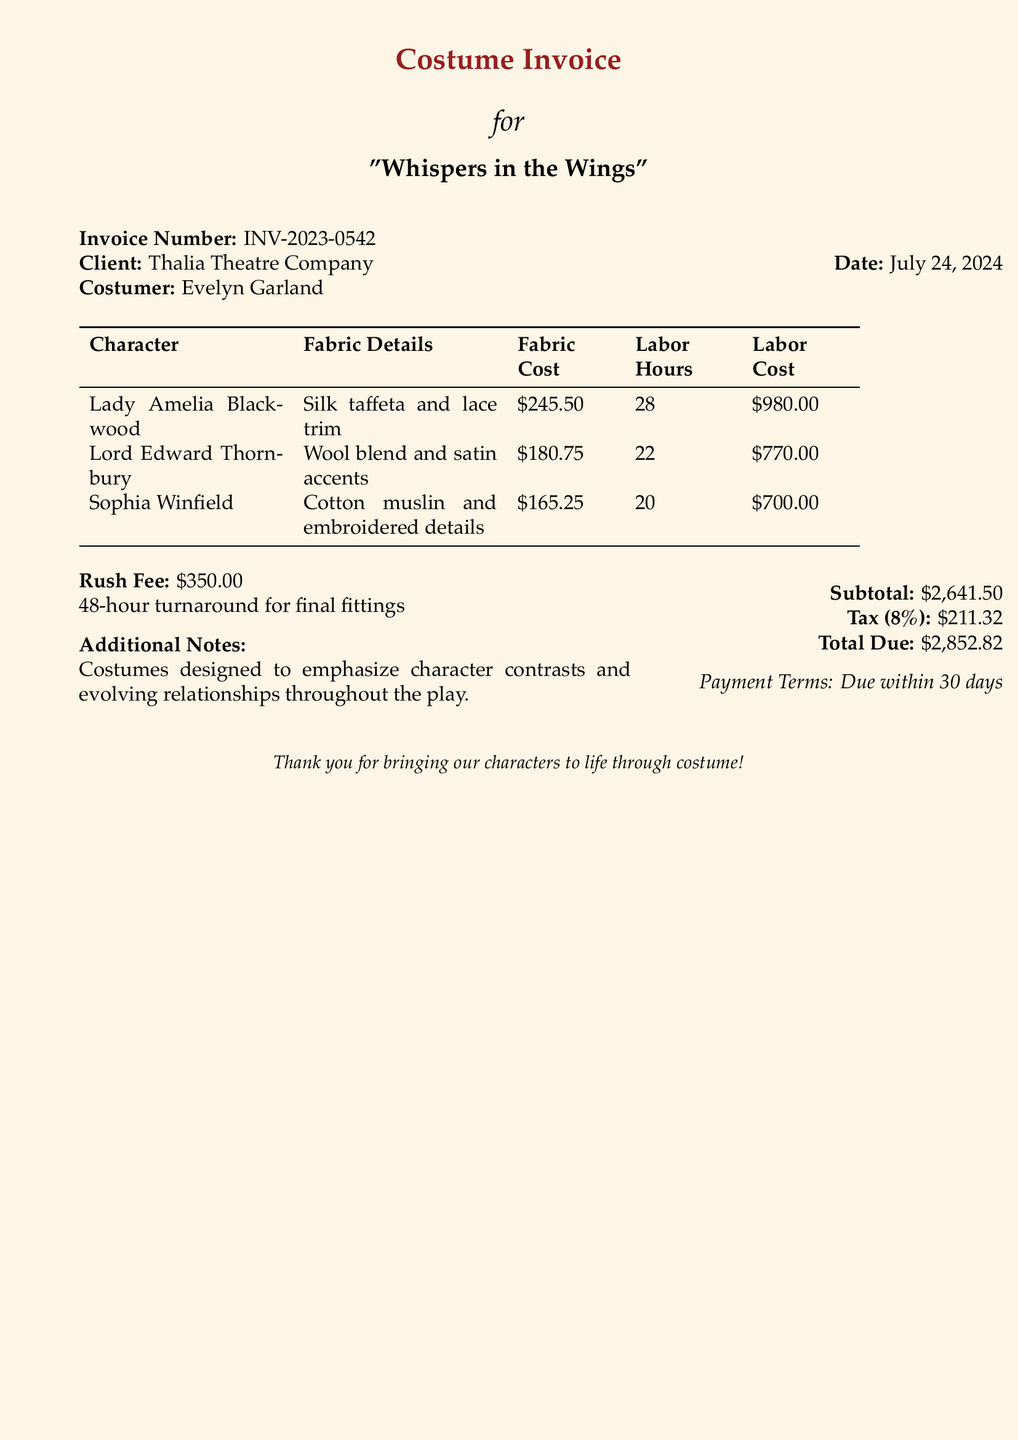what is the invoice number? The invoice number listed in the document is defined as INV-2023-0542.
Answer: INV-2023-0542 who is the client? The client for the costumes is specified as Thalia Theatre Company.
Answer: Thalia Theatre Company what is the total due? The total due is calculated by adding the subtotal and tax components given in the document. The total due is $2,852.82.
Answer: $2,852.82 how many labor hours were spent on Lady Amelia Blackwood's costume? The document states that 28 labor hours were spent on Lady Amelia Blackwood's costume.
Answer: 28 what is the fabric cost for Lord Edward Thornbury? The fabric cost for Lord Edward Thornbury is detailed as $180.75 in the document.
Answer: $180.75 what is the rush fee? The rush fee for the costume work is noted as $350.00.
Answer: $350.00 how does the design emphasize character relationships? The document mentions that costumes are designed to emphasize character contrasts and evolving relationships throughout the play.
Answer: emphasis on character contrasts and evolving relationships what percentage is the tax? The tax percentage applied in the document is stated as 8%.
Answer: 8% how many costumes are listed in the invoice? The invoice lists a total of three costumes for different characters, indicating the number of costumes.
Answer: three 